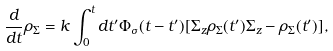Convert formula to latex. <formula><loc_0><loc_0><loc_500><loc_500>\frac { d } { d t } \rho _ { \Sigma } = k \int _ { 0 } ^ { t } d t ^ { \prime } \Phi _ { \sigma } ( t - t ^ { \prime } ) [ \Sigma _ { z } \rho _ { \Sigma } ( t ^ { \prime } ) \Sigma _ { z } - \rho _ { \Sigma } ( t ^ { \prime } ) ] ,</formula> 